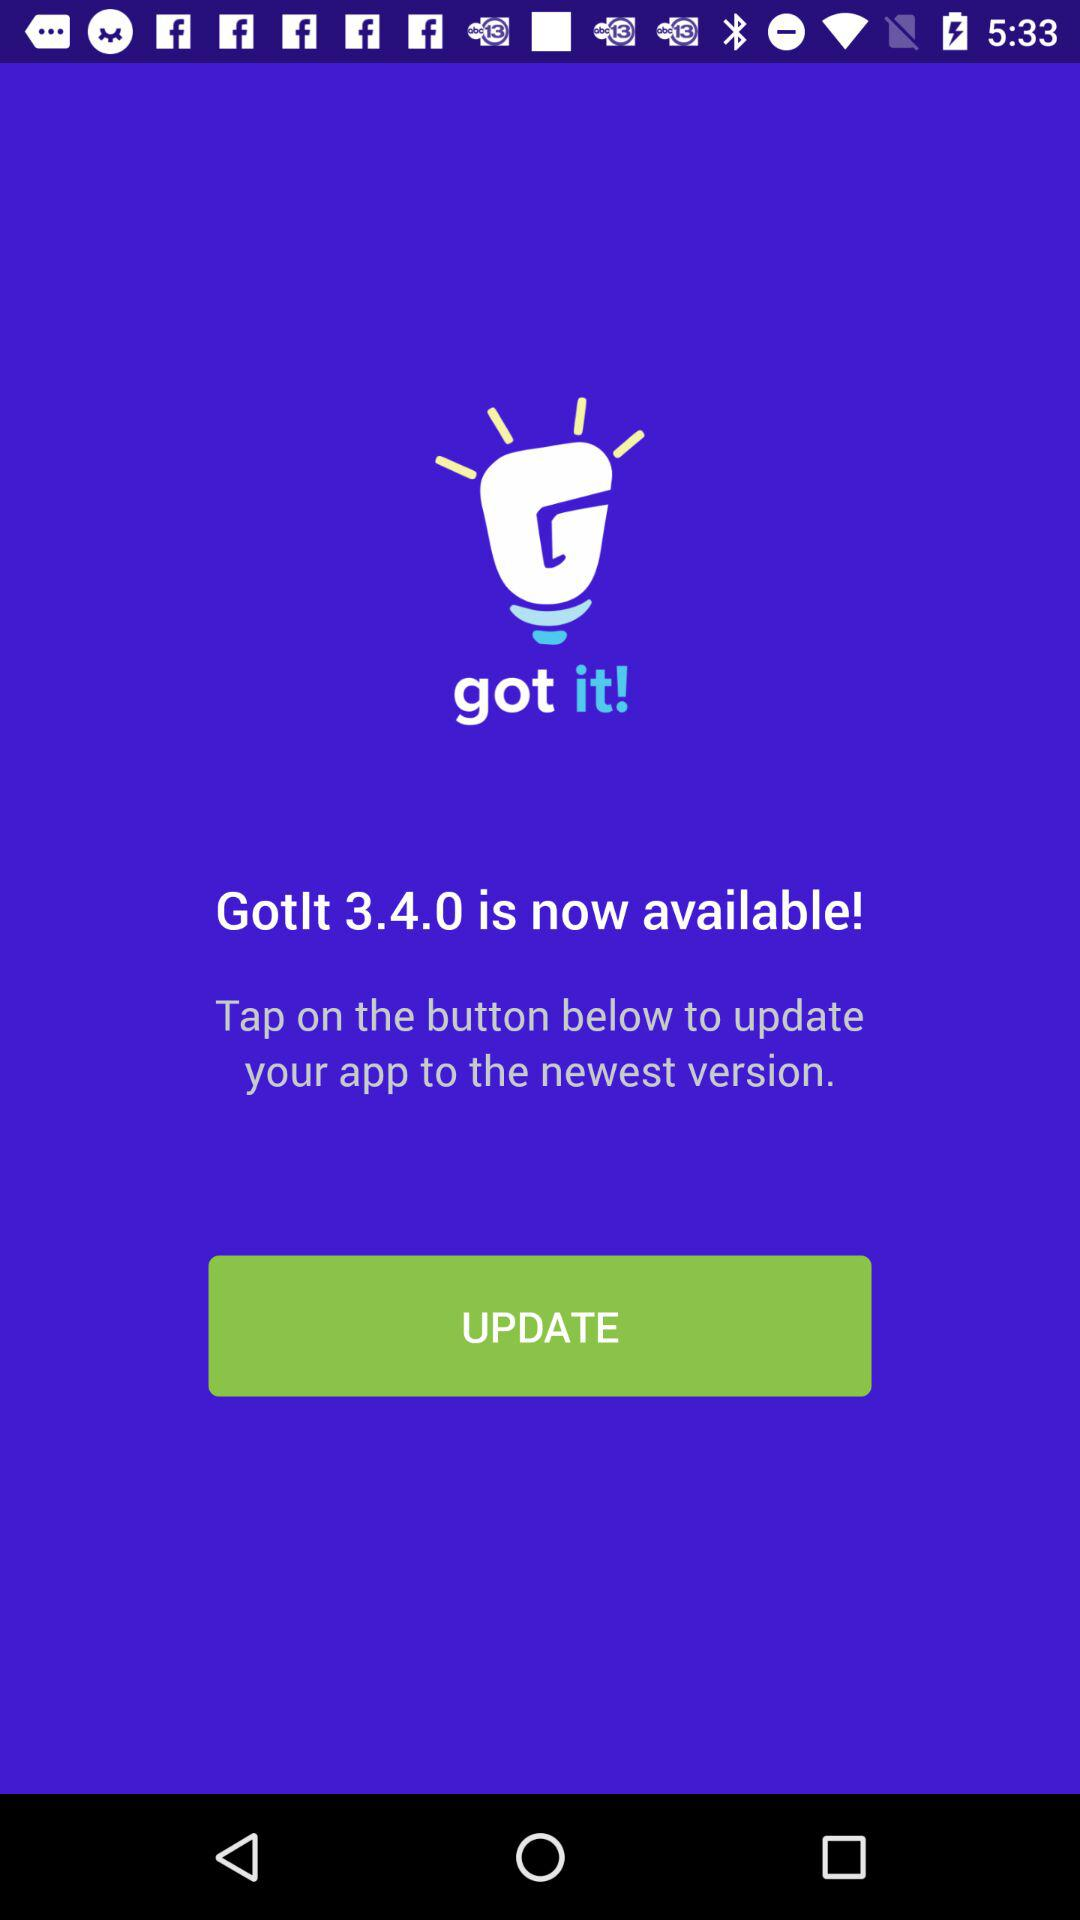What is the newest version? The newest version is 3.4.0. 